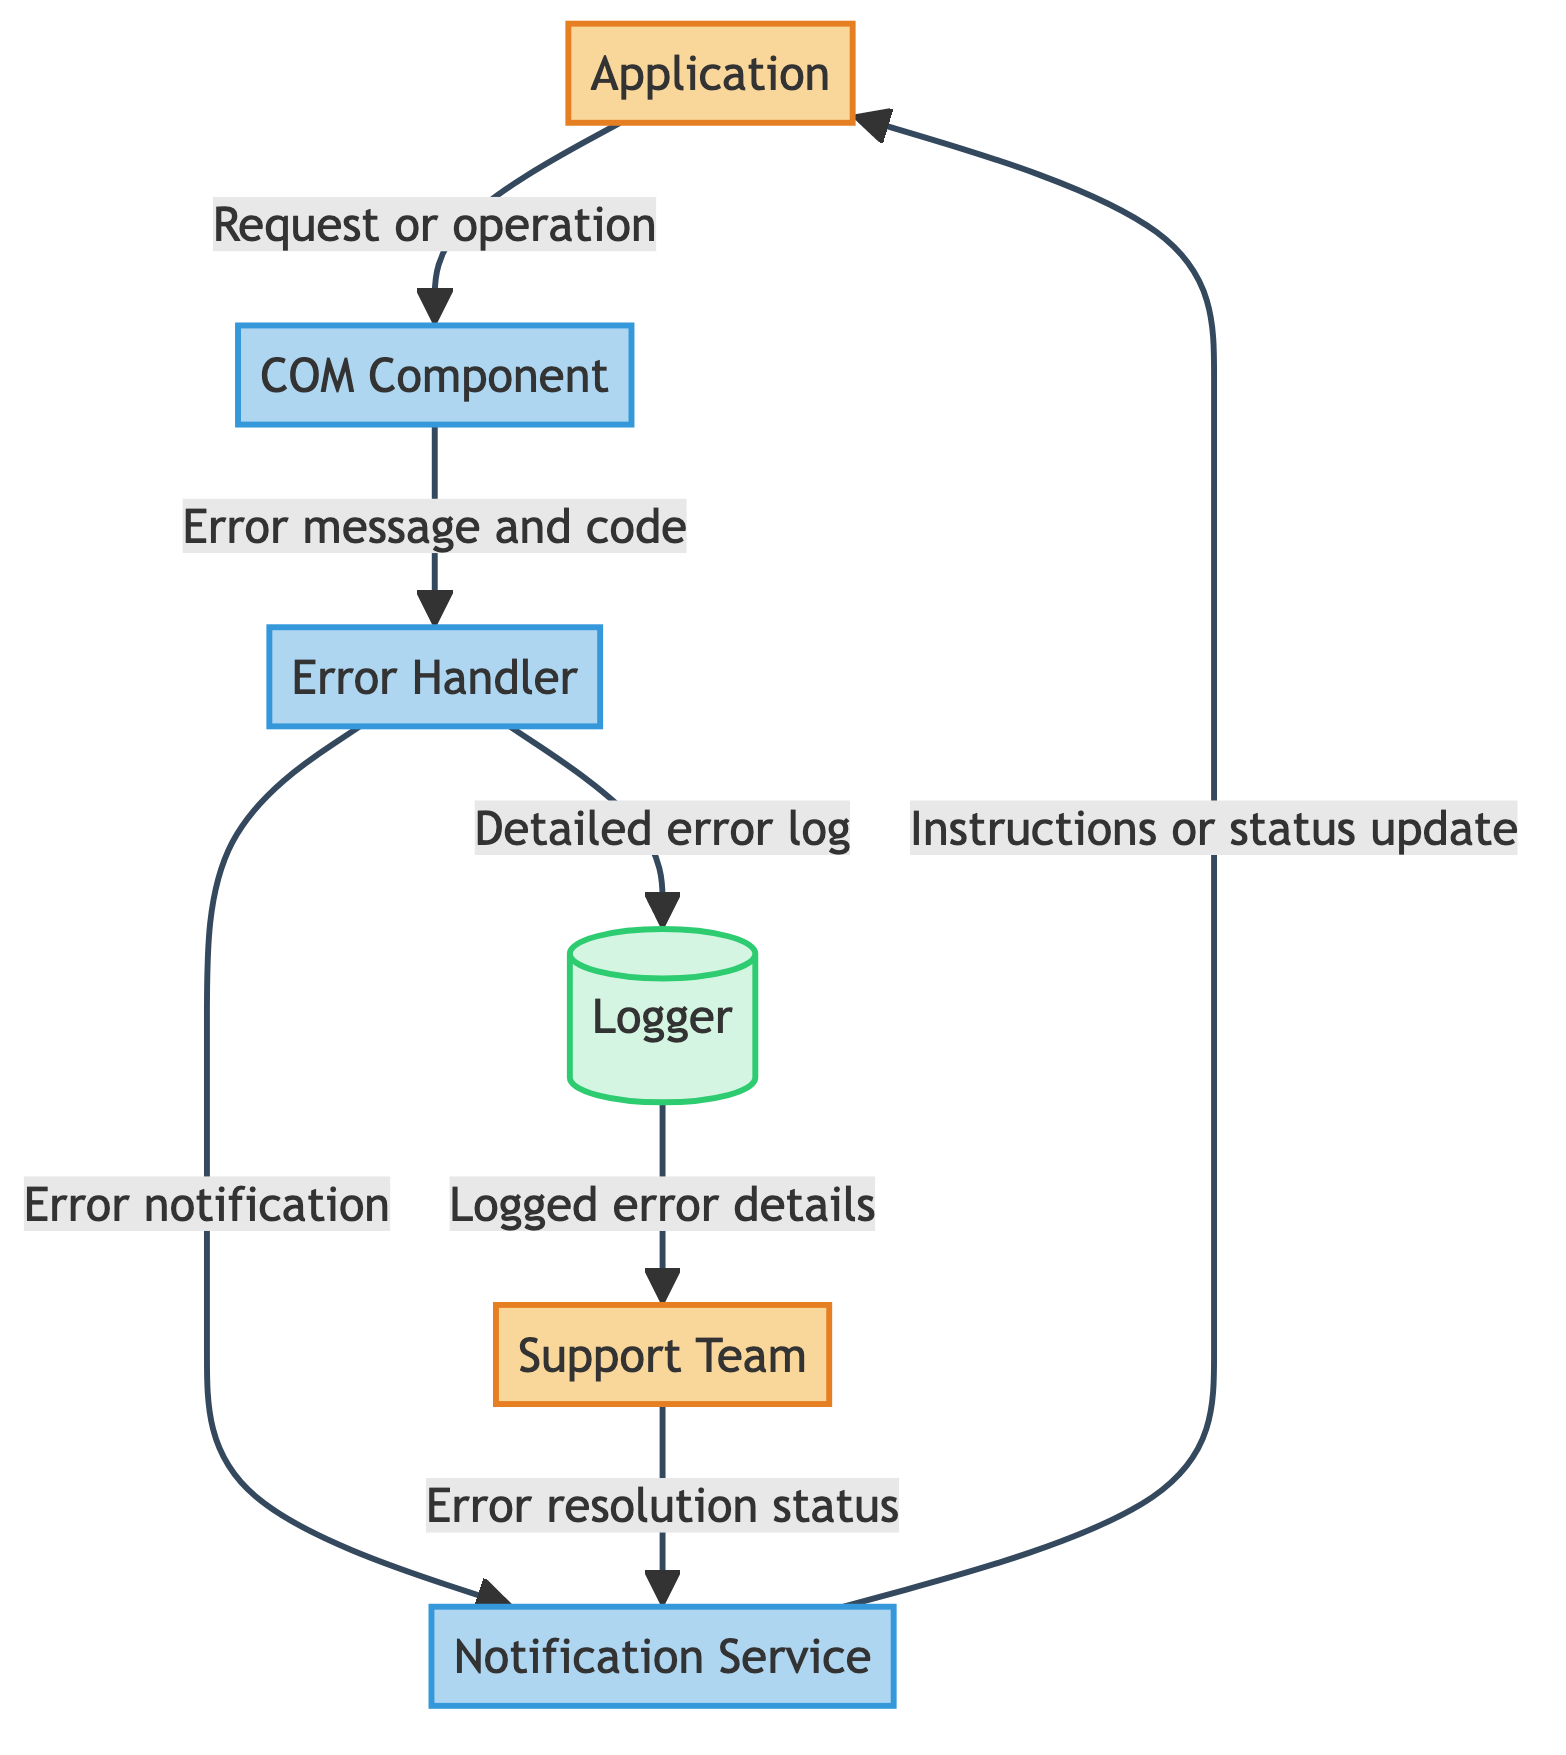What is the main external entity in the diagram? The diagram represents the main software application as the primary external entity, labeled "Application."
Answer: Application How many processes are depicted in the diagram? The diagram includes four distinct processes: COM Component, Error Handler, Logger, and Notification Service.
Answer: Four What data flows from the COM Component to the Error Handler? The data flowing from the COM Component to the Error Handler is specified as "Error message and code."
Answer: Error message and code Which component informs the Support Team about logged errors? The Logger is responsible for sending "Logged error details" to the Support Team.
Answer: Logger What type of flow goes from the Support Team to the Notification Service? The flow from the Support Team to the Notification Service consists of the "Error resolution status."
Answer: Error resolution status What kind of module is responsible for catching and handling errors? The module designated for catching and handling errors in the diagram is labeled as "Error Handler."
Answer: Error Handler What flows from the Error Handler to the Logger? The flow from the Error Handler to the Logger is a "Detailed error log."
Answer: Detailed error log How many external entities are involved in the error handling process? There are two external entities directly involved in the error handling process: Application and Support Team.
Answer: Two What is the last flow that provides feedback to the main application? The last flow that provides feedback to the main application is an "Instructions or status update" from the Notification Service.
Answer: Instructions or status update 